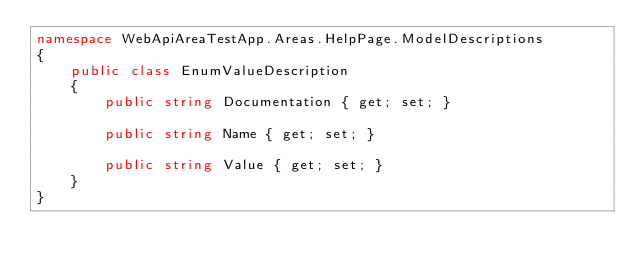Convert code to text. <code><loc_0><loc_0><loc_500><loc_500><_C#_>namespace WebApiAreaTestApp.Areas.HelpPage.ModelDescriptions
{
    public class EnumValueDescription
    {
        public string Documentation { get; set; }

        public string Name { get; set; }

        public string Value { get; set; }
    }
}</code> 